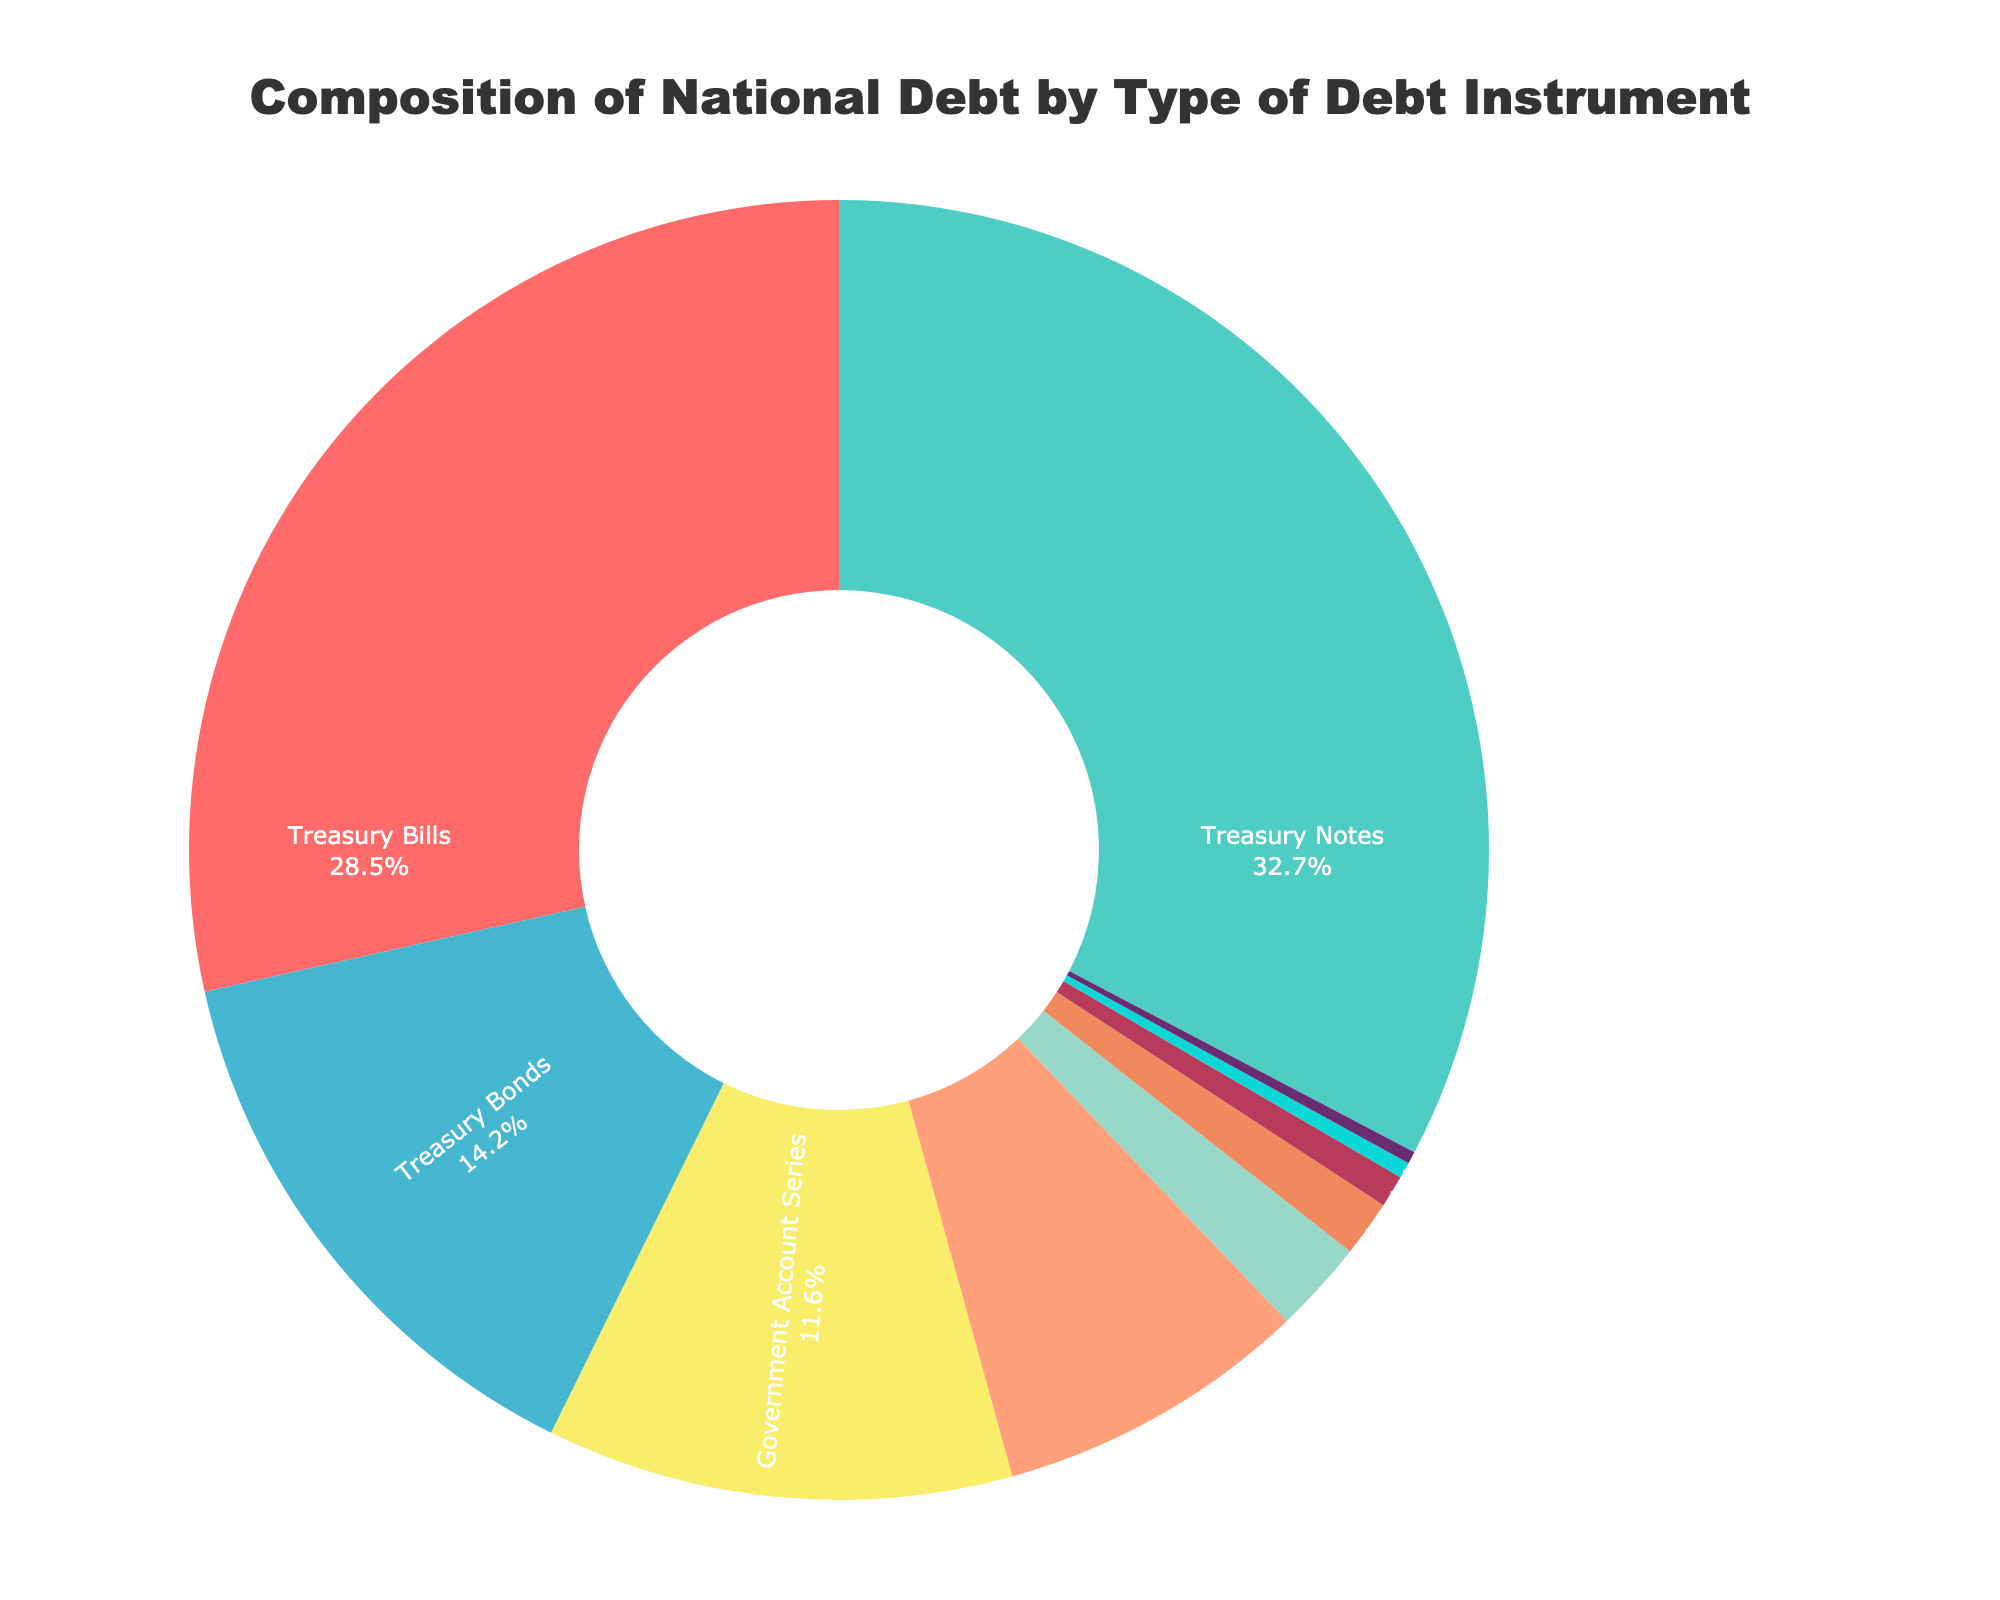What's the total percentage of the national debt held in Treasury Notes and Treasury Bonds? To find the total percentage held in Treasury Notes and Treasury Bonds, add their individual percentages from the pie chart: 32.7% (Treasury Notes) + 14.2% (Treasury Bonds) = 46.9%
Answer: 46.9% Which type of debt instrument has the smallest percentage? By looking at the pie chart, the smallest segment represents Domestic Series with 0.3%.
Answer: Domestic Series How does the percentage of Treasury Inflation-Protected Securities (TIPS) compare to Government Account Series? Compare the percentages of TIPS (7.8%) and Government Account Series (11.6%); TIPS has a smaller percentage.
Answer: TIPS has a smaller percentage Which debt instrument is represented by the green segment? The green segment represents Treasury Bills.
Answer: Treasury Bills What is the difference in percentage between Savings Bonds and State and Local Government Series? To find the difference, subtract the percentage of Savings Bonds (0.4%) from the State and Local Government Series (1.4%): 1.4% - 0.4% = 1%
Answer: 1% What proportion of the national debt is held in Federal Financing Bank Securities, State and Local Government Series, and Foreign Government Series collectively? Add the percentages of Federal Financing Bank Securities (2.3%), State and Local Government Series (1.4%), and Foreign Government Series (0.8%): 2.3% + 1.4% + 0.8% = 4.5%
Answer: 4.5% Which type of debt instrument has the largest percentage? By examining the pie chart, the largest segment represents Treasury Notes with 32.7%.
Answer: Treasury Notes What is the average percentage of Treasury Bills, Treasury Bonds, and Savings Bonds combined? Calculate the average percentage by summing the percentages (28.5% + 14.2% + 0.4%) and then dividing by 3: (28.5% + 14.2% + 0.4%) / 3 = 14.37%
Answer: 14.37% Is there more national debt held in Treasury Inflation-Protected Securities (TIPS) or Government Account Series? Compare the percentages directly: TIPS (7.8%) is less than Government Account Series (11.6%).
Answer: Government Account Series What is the combined percentage of Treasury Bills and TIPS? Add the percentages of Treasury Bills (28.5%) and TIPS (7.8%): 28.5% + 7.8% = 36.3%
Answer: 36.3% 